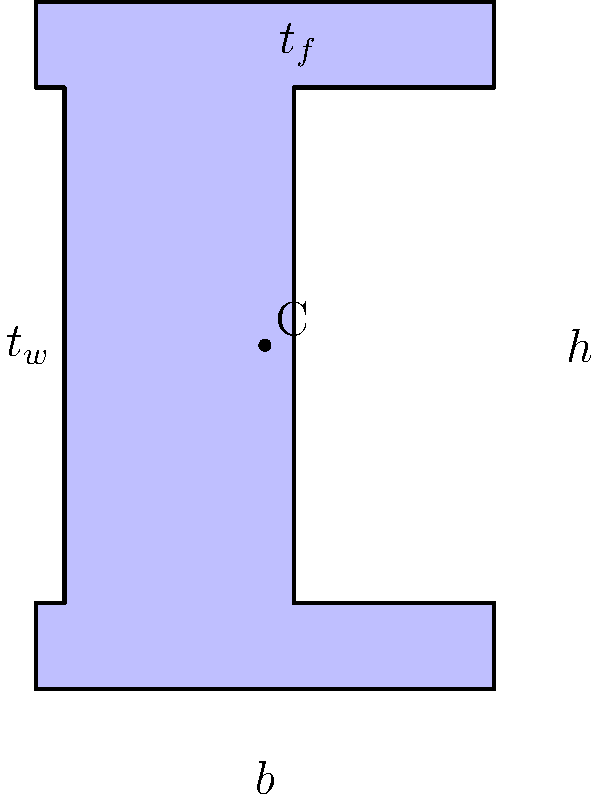As a fashion model with flawless skin, you appreciate precision and symmetry. In civil engineering, the I-beam's cross-section shown above is designed with similar attention to detail. If the beam has dimensions $h=6$ in, $b=4$ in, $t_w=0.5$ in, and $t_f=0.75$ in, calculate the moment of inertia $I_x$ about the x-axis (centroidal axis) of this I-beam cross-section. Let's approach this step-by-step, much like how a skilled surgeon precisely plans each incision:

1) The moment of inertia for an I-beam can be calculated by dividing it into three rectangles: two flanges and one web.

2) For a rectangle about its centroidal axis: $I = \frac{bh^3}{12}$

3) For the top and bottom flanges:
   $I_f = 2 \cdot \frac{b \cdot t_f^3}{12} = 2 \cdot \frac{4 \cdot 0.75^3}{12} = 0.070313$ in⁴

4) For the web:
   $I_w = \frac{t_w \cdot (h-2t_f)^3}{12} = \frac{0.5 \cdot (6-2\cdot0.75)^3}{12} = 4.21875$ in⁴

5) We need to add the parallel axis theorem for the flanges:
   $A_f = b \cdot t_f = 4 \cdot 0.75 = 3$ in²
   $d = \frac{h}{2} - \frac{t_f}{2} = \frac{6}{2} - \frac{0.75}{2} = 2.625$ in
   $I_{parallel} = 2 \cdot (A_f \cdot d^2) = 2 \cdot (3 \cdot 2.625^2) = 41.34375$ in⁴

6) The total moment of inertia is the sum of all parts:
   $I_x = I_f + I_w + I_{parallel} = 0.070313 + 4.21875 + 41.34375 = 45.632813$ in⁴

7) Rounding to four decimal places: $I_x = 45.6328$ in⁴
Answer: $45.6328$ in⁴ 